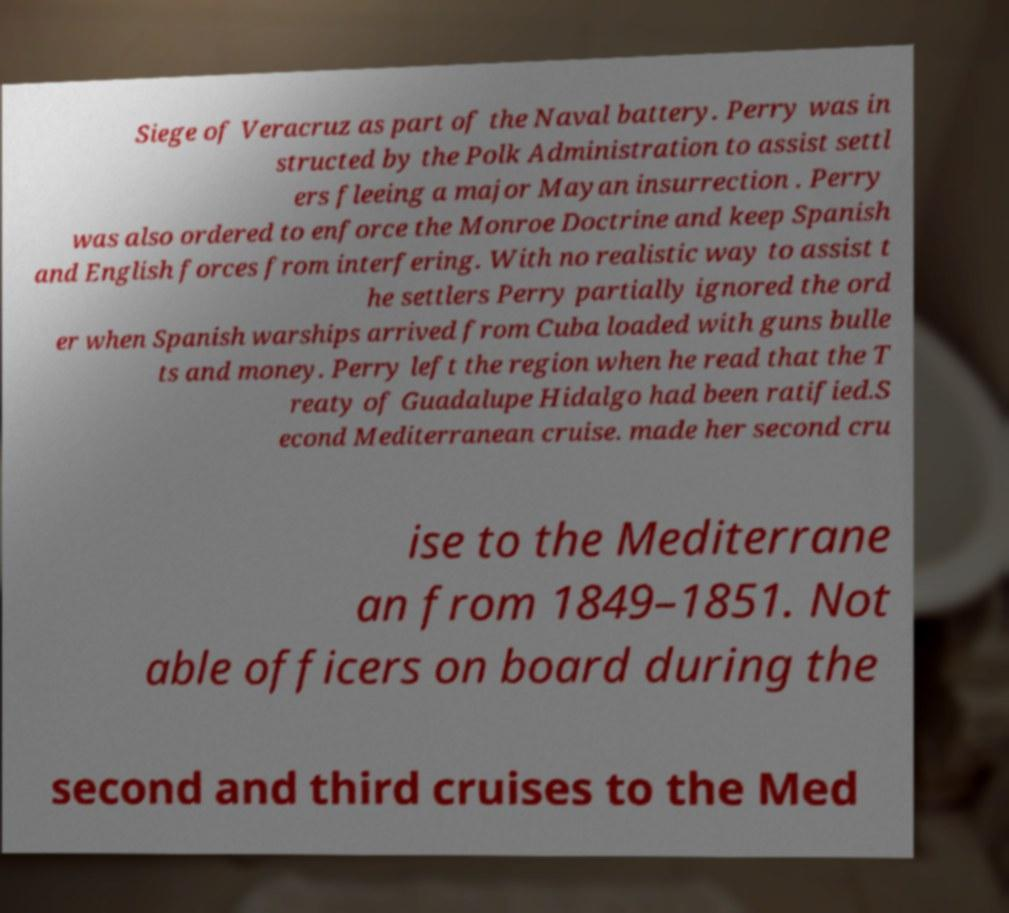Please read and relay the text visible in this image. What does it say? Siege of Veracruz as part of the Naval battery. Perry was in structed by the Polk Administration to assist settl ers fleeing a major Mayan insurrection . Perry was also ordered to enforce the Monroe Doctrine and keep Spanish and English forces from interfering. With no realistic way to assist t he settlers Perry partially ignored the ord er when Spanish warships arrived from Cuba loaded with guns bulle ts and money. Perry left the region when he read that the T reaty of Guadalupe Hidalgo had been ratified.S econd Mediterranean cruise. made her second cru ise to the Mediterrane an from 1849–1851. Not able officers on board during the second and third cruises to the Med 